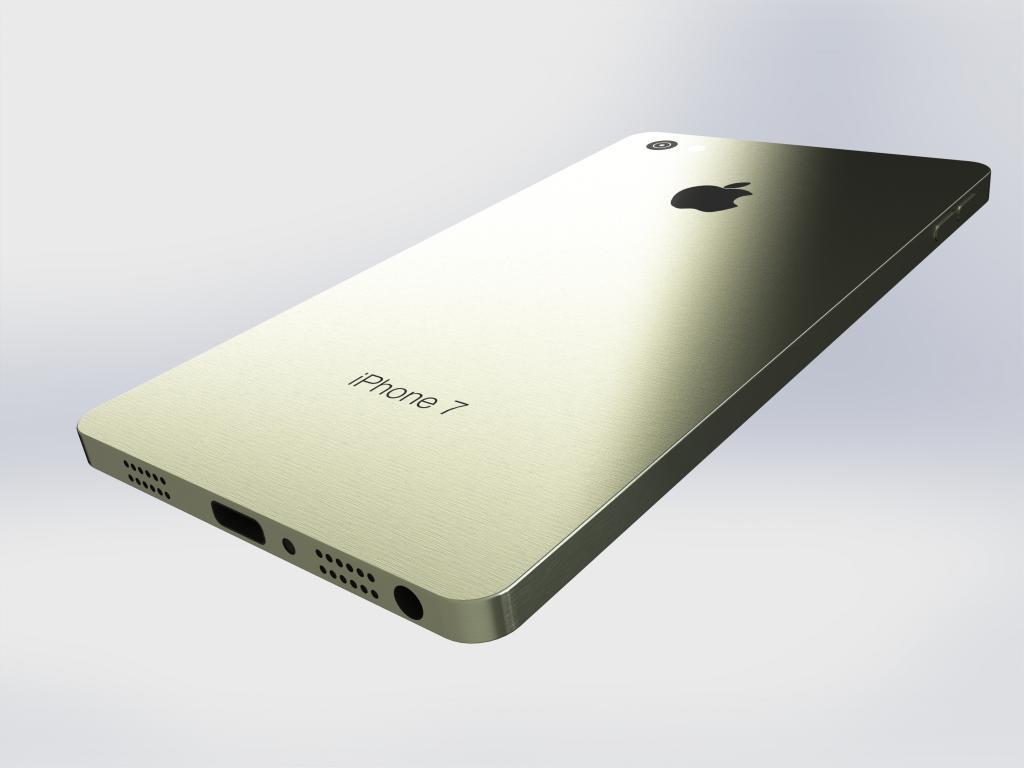<image>
Offer a succinct explanation of the picture presented. An iPhone 7 sits face down in an empty void. 